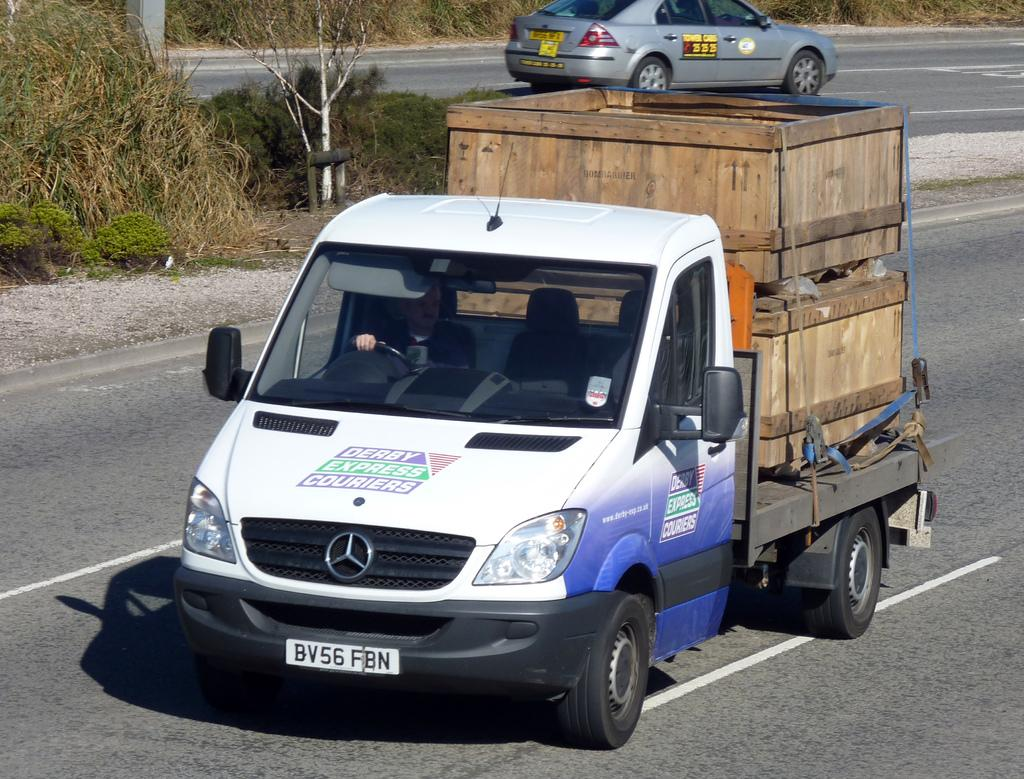Provide a one-sentence caption for the provided image. A van with Derby Express Couriers written on it and two wooden crates on the back. 